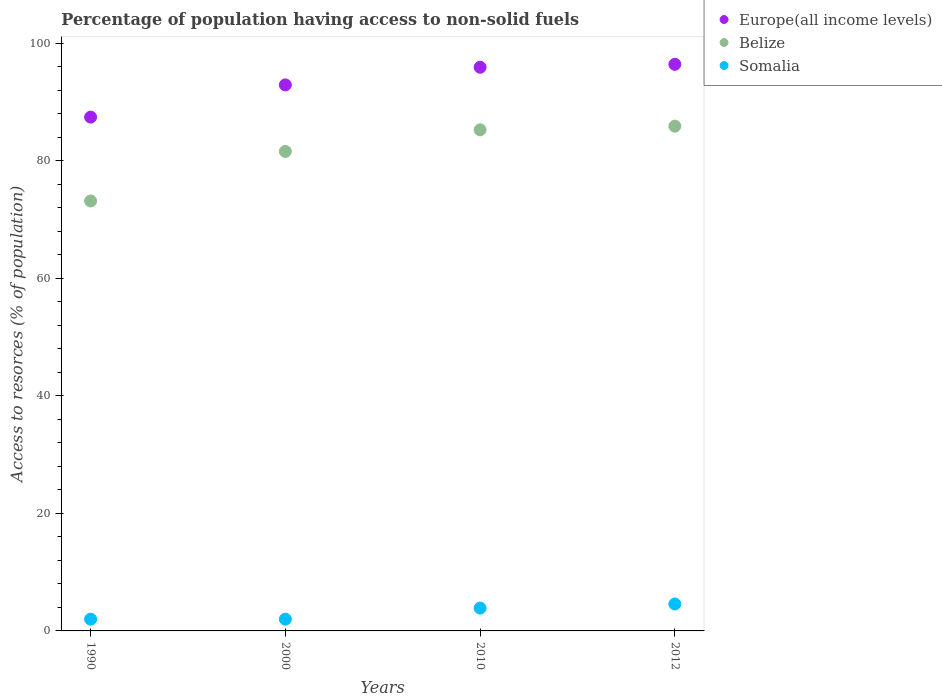Is the number of dotlines equal to the number of legend labels?
Give a very brief answer. Yes. What is the percentage of population having access to non-solid fuels in Belize in 1990?
Offer a very short reply. 73.17. Across all years, what is the maximum percentage of population having access to non-solid fuels in Europe(all income levels)?
Offer a very short reply. 96.42. Across all years, what is the minimum percentage of population having access to non-solid fuels in Europe(all income levels)?
Your answer should be very brief. 87.44. What is the total percentage of population having access to non-solid fuels in Belize in the graph?
Keep it short and to the point. 325.93. What is the difference between the percentage of population having access to non-solid fuels in Europe(all income levels) in 2000 and that in 2010?
Ensure brevity in your answer.  -3.01. What is the difference between the percentage of population having access to non-solid fuels in Belize in 2000 and the percentage of population having access to non-solid fuels in Somalia in 2012?
Provide a short and direct response. 77.01. What is the average percentage of population having access to non-solid fuels in Somalia per year?
Offer a very short reply. 3.12. In the year 2012, what is the difference between the percentage of population having access to non-solid fuels in Somalia and percentage of population having access to non-solid fuels in Belize?
Give a very brief answer. -81.31. In how many years, is the percentage of population having access to non-solid fuels in Belize greater than 56 %?
Provide a short and direct response. 4. What is the ratio of the percentage of population having access to non-solid fuels in Europe(all income levels) in 2000 to that in 2010?
Provide a short and direct response. 0.97. Is the difference between the percentage of population having access to non-solid fuels in Somalia in 2000 and 2010 greater than the difference between the percentage of population having access to non-solid fuels in Belize in 2000 and 2010?
Your answer should be compact. Yes. What is the difference between the highest and the second highest percentage of population having access to non-solid fuels in Somalia?
Offer a terse response. 0.7. What is the difference between the highest and the lowest percentage of population having access to non-solid fuels in Somalia?
Give a very brief answer. 2.58. In how many years, is the percentage of population having access to non-solid fuels in Belize greater than the average percentage of population having access to non-solid fuels in Belize taken over all years?
Your answer should be compact. 3. Is the sum of the percentage of population having access to non-solid fuels in Europe(all income levels) in 1990 and 2012 greater than the maximum percentage of population having access to non-solid fuels in Belize across all years?
Give a very brief answer. Yes. Is the percentage of population having access to non-solid fuels in Belize strictly greater than the percentage of population having access to non-solid fuels in Europe(all income levels) over the years?
Make the answer very short. No. Is the percentage of population having access to non-solid fuels in Somalia strictly less than the percentage of population having access to non-solid fuels in Belize over the years?
Make the answer very short. Yes. How many dotlines are there?
Your answer should be very brief. 3. How many years are there in the graph?
Provide a short and direct response. 4. What is the difference between two consecutive major ticks on the Y-axis?
Ensure brevity in your answer.  20. Are the values on the major ticks of Y-axis written in scientific E-notation?
Keep it short and to the point. No. Does the graph contain any zero values?
Give a very brief answer. No. Where does the legend appear in the graph?
Provide a short and direct response. Top right. How are the legend labels stacked?
Provide a succinct answer. Vertical. What is the title of the graph?
Your response must be concise. Percentage of population having access to non-solid fuels. What is the label or title of the Y-axis?
Your answer should be very brief. Access to resorces (% of population). What is the Access to resorces (% of population) in Europe(all income levels) in 1990?
Ensure brevity in your answer.  87.44. What is the Access to resorces (% of population) of Belize in 1990?
Keep it short and to the point. 73.17. What is the Access to resorces (% of population) in Somalia in 1990?
Provide a succinct answer. 2. What is the Access to resorces (% of population) in Europe(all income levels) in 2000?
Keep it short and to the point. 92.92. What is the Access to resorces (% of population) of Belize in 2000?
Your answer should be very brief. 81.6. What is the Access to resorces (% of population) in Somalia in 2000?
Keep it short and to the point. 2. What is the Access to resorces (% of population) of Europe(all income levels) in 2010?
Ensure brevity in your answer.  95.92. What is the Access to resorces (% of population) in Belize in 2010?
Offer a very short reply. 85.27. What is the Access to resorces (% of population) in Somalia in 2010?
Your response must be concise. 3.89. What is the Access to resorces (% of population) in Europe(all income levels) in 2012?
Provide a succinct answer. 96.42. What is the Access to resorces (% of population) of Belize in 2012?
Keep it short and to the point. 85.89. What is the Access to resorces (% of population) of Somalia in 2012?
Your answer should be compact. 4.58. Across all years, what is the maximum Access to resorces (% of population) in Europe(all income levels)?
Your answer should be very brief. 96.42. Across all years, what is the maximum Access to resorces (% of population) in Belize?
Provide a short and direct response. 85.89. Across all years, what is the maximum Access to resorces (% of population) in Somalia?
Provide a short and direct response. 4.58. Across all years, what is the minimum Access to resorces (% of population) in Europe(all income levels)?
Your answer should be compact. 87.44. Across all years, what is the minimum Access to resorces (% of population) of Belize?
Ensure brevity in your answer.  73.17. Across all years, what is the minimum Access to resorces (% of population) in Somalia?
Give a very brief answer. 2. What is the total Access to resorces (% of population) of Europe(all income levels) in the graph?
Offer a very short reply. 372.69. What is the total Access to resorces (% of population) of Belize in the graph?
Offer a terse response. 325.93. What is the total Access to resorces (% of population) in Somalia in the graph?
Make the answer very short. 12.47. What is the difference between the Access to resorces (% of population) in Europe(all income levels) in 1990 and that in 2000?
Give a very brief answer. -5.48. What is the difference between the Access to resorces (% of population) of Belize in 1990 and that in 2000?
Give a very brief answer. -8.43. What is the difference between the Access to resorces (% of population) of Europe(all income levels) in 1990 and that in 2010?
Give a very brief answer. -8.49. What is the difference between the Access to resorces (% of population) in Belize in 1990 and that in 2010?
Your response must be concise. -12.1. What is the difference between the Access to resorces (% of population) of Somalia in 1990 and that in 2010?
Your answer should be compact. -1.89. What is the difference between the Access to resorces (% of population) in Europe(all income levels) in 1990 and that in 2012?
Keep it short and to the point. -8.98. What is the difference between the Access to resorces (% of population) of Belize in 1990 and that in 2012?
Provide a succinct answer. -12.73. What is the difference between the Access to resorces (% of population) in Somalia in 1990 and that in 2012?
Keep it short and to the point. -2.58. What is the difference between the Access to resorces (% of population) of Europe(all income levels) in 2000 and that in 2010?
Your response must be concise. -3.01. What is the difference between the Access to resorces (% of population) of Belize in 2000 and that in 2010?
Your response must be concise. -3.67. What is the difference between the Access to resorces (% of population) of Somalia in 2000 and that in 2010?
Your answer should be very brief. -1.89. What is the difference between the Access to resorces (% of population) of Europe(all income levels) in 2000 and that in 2012?
Offer a terse response. -3.5. What is the difference between the Access to resorces (% of population) of Belize in 2000 and that in 2012?
Your response must be concise. -4.3. What is the difference between the Access to resorces (% of population) in Somalia in 2000 and that in 2012?
Make the answer very short. -2.58. What is the difference between the Access to resorces (% of population) in Europe(all income levels) in 2010 and that in 2012?
Your response must be concise. -0.5. What is the difference between the Access to resorces (% of population) of Belize in 2010 and that in 2012?
Provide a short and direct response. -0.62. What is the difference between the Access to resorces (% of population) of Somalia in 2010 and that in 2012?
Ensure brevity in your answer.  -0.7. What is the difference between the Access to resorces (% of population) in Europe(all income levels) in 1990 and the Access to resorces (% of population) in Belize in 2000?
Provide a short and direct response. 5.84. What is the difference between the Access to resorces (% of population) of Europe(all income levels) in 1990 and the Access to resorces (% of population) of Somalia in 2000?
Provide a short and direct response. 85.44. What is the difference between the Access to resorces (% of population) of Belize in 1990 and the Access to resorces (% of population) of Somalia in 2000?
Offer a very short reply. 71.17. What is the difference between the Access to resorces (% of population) in Europe(all income levels) in 1990 and the Access to resorces (% of population) in Belize in 2010?
Keep it short and to the point. 2.17. What is the difference between the Access to resorces (% of population) of Europe(all income levels) in 1990 and the Access to resorces (% of population) of Somalia in 2010?
Your answer should be compact. 83.55. What is the difference between the Access to resorces (% of population) of Belize in 1990 and the Access to resorces (% of population) of Somalia in 2010?
Ensure brevity in your answer.  69.28. What is the difference between the Access to resorces (% of population) of Europe(all income levels) in 1990 and the Access to resorces (% of population) of Belize in 2012?
Ensure brevity in your answer.  1.54. What is the difference between the Access to resorces (% of population) of Europe(all income levels) in 1990 and the Access to resorces (% of population) of Somalia in 2012?
Keep it short and to the point. 82.85. What is the difference between the Access to resorces (% of population) of Belize in 1990 and the Access to resorces (% of population) of Somalia in 2012?
Your response must be concise. 68.58. What is the difference between the Access to resorces (% of population) of Europe(all income levels) in 2000 and the Access to resorces (% of population) of Belize in 2010?
Make the answer very short. 7.65. What is the difference between the Access to resorces (% of population) of Europe(all income levels) in 2000 and the Access to resorces (% of population) of Somalia in 2010?
Keep it short and to the point. 89.03. What is the difference between the Access to resorces (% of population) of Belize in 2000 and the Access to resorces (% of population) of Somalia in 2010?
Make the answer very short. 77.71. What is the difference between the Access to resorces (% of population) in Europe(all income levels) in 2000 and the Access to resorces (% of population) in Belize in 2012?
Ensure brevity in your answer.  7.02. What is the difference between the Access to resorces (% of population) in Europe(all income levels) in 2000 and the Access to resorces (% of population) in Somalia in 2012?
Your answer should be very brief. 88.33. What is the difference between the Access to resorces (% of population) of Belize in 2000 and the Access to resorces (% of population) of Somalia in 2012?
Provide a short and direct response. 77.01. What is the difference between the Access to resorces (% of population) of Europe(all income levels) in 2010 and the Access to resorces (% of population) of Belize in 2012?
Your answer should be compact. 10.03. What is the difference between the Access to resorces (% of population) of Europe(all income levels) in 2010 and the Access to resorces (% of population) of Somalia in 2012?
Your answer should be compact. 91.34. What is the difference between the Access to resorces (% of population) in Belize in 2010 and the Access to resorces (% of population) in Somalia in 2012?
Provide a short and direct response. 80.69. What is the average Access to resorces (% of population) in Europe(all income levels) per year?
Give a very brief answer. 93.17. What is the average Access to resorces (% of population) of Belize per year?
Give a very brief answer. 81.48. What is the average Access to resorces (% of population) of Somalia per year?
Your answer should be very brief. 3.12. In the year 1990, what is the difference between the Access to resorces (% of population) of Europe(all income levels) and Access to resorces (% of population) of Belize?
Your answer should be very brief. 14.27. In the year 1990, what is the difference between the Access to resorces (% of population) of Europe(all income levels) and Access to resorces (% of population) of Somalia?
Your answer should be compact. 85.44. In the year 1990, what is the difference between the Access to resorces (% of population) in Belize and Access to resorces (% of population) in Somalia?
Offer a very short reply. 71.17. In the year 2000, what is the difference between the Access to resorces (% of population) of Europe(all income levels) and Access to resorces (% of population) of Belize?
Make the answer very short. 11.32. In the year 2000, what is the difference between the Access to resorces (% of population) of Europe(all income levels) and Access to resorces (% of population) of Somalia?
Provide a succinct answer. 90.92. In the year 2000, what is the difference between the Access to resorces (% of population) of Belize and Access to resorces (% of population) of Somalia?
Make the answer very short. 79.6. In the year 2010, what is the difference between the Access to resorces (% of population) of Europe(all income levels) and Access to resorces (% of population) of Belize?
Make the answer very short. 10.65. In the year 2010, what is the difference between the Access to resorces (% of population) of Europe(all income levels) and Access to resorces (% of population) of Somalia?
Offer a very short reply. 92.04. In the year 2010, what is the difference between the Access to resorces (% of population) of Belize and Access to resorces (% of population) of Somalia?
Provide a succinct answer. 81.38. In the year 2012, what is the difference between the Access to resorces (% of population) of Europe(all income levels) and Access to resorces (% of population) of Belize?
Provide a short and direct response. 10.53. In the year 2012, what is the difference between the Access to resorces (% of population) of Europe(all income levels) and Access to resorces (% of population) of Somalia?
Offer a terse response. 91.84. In the year 2012, what is the difference between the Access to resorces (% of population) in Belize and Access to resorces (% of population) in Somalia?
Provide a succinct answer. 81.31. What is the ratio of the Access to resorces (% of population) of Europe(all income levels) in 1990 to that in 2000?
Your answer should be compact. 0.94. What is the ratio of the Access to resorces (% of population) of Belize in 1990 to that in 2000?
Provide a short and direct response. 0.9. What is the ratio of the Access to resorces (% of population) of Somalia in 1990 to that in 2000?
Keep it short and to the point. 1. What is the ratio of the Access to resorces (% of population) of Europe(all income levels) in 1990 to that in 2010?
Make the answer very short. 0.91. What is the ratio of the Access to resorces (% of population) in Belize in 1990 to that in 2010?
Give a very brief answer. 0.86. What is the ratio of the Access to resorces (% of population) in Somalia in 1990 to that in 2010?
Make the answer very short. 0.51. What is the ratio of the Access to resorces (% of population) of Europe(all income levels) in 1990 to that in 2012?
Offer a very short reply. 0.91. What is the ratio of the Access to resorces (% of population) of Belize in 1990 to that in 2012?
Offer a terse response. 0.85. What is the ratio of the Access to resorces (% of population) of Somalia in 1990 to that in 2012?
Your answer should be compact. 0.44. What is the ratio of the Access to resorces (% of population) of Europe(all income levels) in 2000 to that in 2010?
Offer a very short reply. 0.97. What is the ratio of the Access to resorces (% of population) of Belize in 2000 to that in 2010?
Ensure brevity in your answer.  0.96. What is the ratio of the Access to resorces (% of population) in Somalia in 2000 to that in 2010?
Ensure brevity in your answer.  0.51. What is the ratio of the Access to resorces (% of population) in Europe(all income levels) in 2000 to that in 2012?
Offer a terse response. 0.96. What is the ratio of the Access to resorces (% of population) in Belize in 2000 to that in 2012?
Your response must be concise. 0.95. What is the ratio of the Access to resorces (% of population) in Somalia in 2000 to that in 2012?
Provide a short and direct response. 0.44. What is the ratio of the Access to resorces (% of population) of Somalia in 2010 to that in 2012?
Your response must be concise. 0.85. What is the difference between the highest and the second highest Access to resorces (% of population) in Europe(all income levels)?
Provide a succinct answer. 0.5. What is the difference between the highest and the second highest Access to resorces (% of population) in Belize?
Offer a terse response. 0.62. What is the difference between the highest and the second highest Access to resorces (% of population) of Somalia?
Offer a very short reply. 0.7. What is the difference between the highest and the lowest Access to resorces (% of population) in Europe(all income levels)?
Give a very brief answer. 8.98. What is the difference between the highest and the lowest Access to resorces (% of population) in Belize?
Your response must be concise. 12.73. What is the difference between the highest and the lowest Access to resorces (% of population) of Somalia?
Make the answer very short. 2.58. 